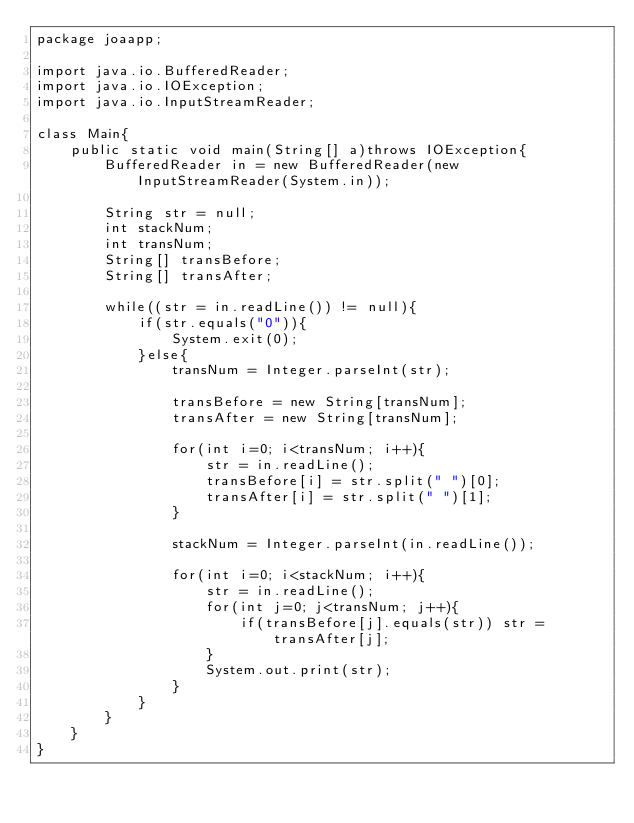Convert code to text. <code><loc_0><loc_0><loc_500><loc_500><_Java_>package joaapp;

import java.io.BufferedReader;
import java.io.IOException;
import java.io.InputStreamReader;

class Main{
    public static void main(String[] a)throws IOException{
    	BufferedReader in = new BufferedReader(new InputStreamReader(System.in));

        String str = null;
        int stackNum;
        int transNum;
        String[] transBefore;
        String[] transAfter;
        
    	while((str = in.readLine()) != null){
            if(str.equals("0")){
                System.exit(0);
            }else{
                transNum = Integer.parseInt(str);
                
                transBefore = new String[transNum];
                transAfter = new String[transNum];
                
                for(int i=0; i<transNum; i++){
                    str = in.readLine();
                    transBefore[i] = str.split(" ")[0];
                    transAfter[i] = str.split(" ")[1];                   
                }
                
                stackNum = Integer.parseInt(in.readLine());
                
                for(int i=0; i<stackNum; i++){
                    str = in.readLine();
                    for(int j=0; j<transNum; j++){
                        if(transBefore[j].equals(str)) str = transAfter[j];
                    }
                    System.out.print(str);
                }
            }
        }
    }
}</code> 